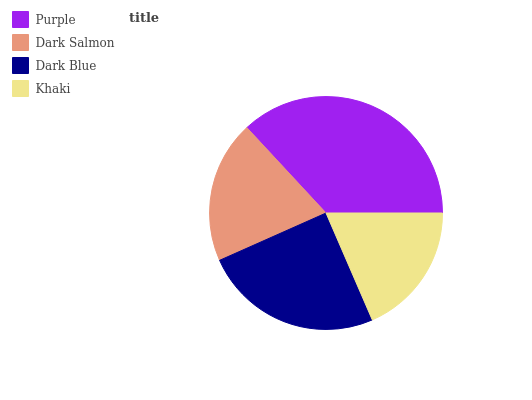Is Khaki the minimum?
Answer yes or no. Yes. Is Purple the maximum?
Answer yes or no. Yes. Is Dark Salmon the minimum?
Answer yes or no. No. Is Dark Salmon the maximum?
Answer yes or no. No. Is Purple greater than Dark Salmon?
Answer yes or no. Yes. Is Dark Salmon less than Purple?
Answer yes or no. Yes. Is Dark Salmon greater than Purple?
Answer yes or no. No. Is Purple less than Dark Salmon?
Answer yes or no. No. Is Dark Blue the high median?
Answer yes or no. Yes. Is Dark Salmon the low median?
Answer yes or no. Yes. Is Purple the high median?
Answer yes or no. No. Is Purple the low median?
Answer yes or no. No. 